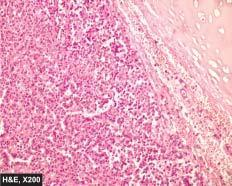what does the tumour show?
Answer the question using a single word or phrase. A characteristic nested of cells separated by fibrovascular septa 